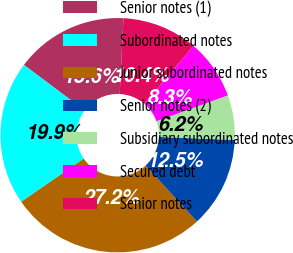<chart> <loc_0><loc_0><loc_500><loc_500><pie_chart><fcel>Senior notes (1)<fcel>Subordinated notes<fcel>Junior subordinated notes<fcel>Senior notes (2)<fcel>Subsidiary subordinated notes<fcel>Secured debt<fcel>Senior notes<nl><fcel>15.55%<fcel>19.86%<fcel>27.2%<fcel>12.52%<fcel>6.17%<fcel>8.29%<fcel>10.4%<nl></chart> 